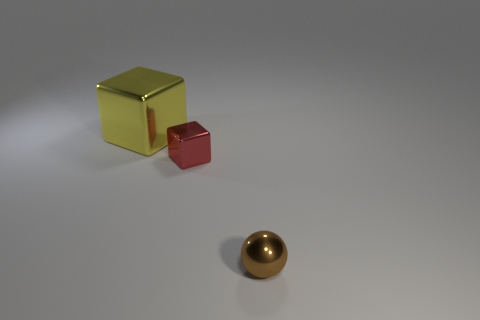What number of purple things are either cubes or big metal things?
Ensure brevity in your answer.  0. Is the number of large blue matte cylinders greater than the number of metallic things?
Ensure brevity in your answer.  No. Does the object on the left side of the small red metallic thing have the same shape as the red metal object?
Your response must be concise. Yes. What number of objects are both in front of the big yellow metallic block and behind the tiny sphere?
Keep it short and to the point. 1. How many other red objects have the same shape as the big thing?
Your response must be concise. 1. What color is the shiny object right of the cube that is in front of the big yellow cube?
Your answer should be compact. Brown. There is a large yellow metallic thing; does it have the same shape as the small thing to the left of the tiny brown thing?
Make the answer very short. Yes. Are there any other metal objects that have the same size as the yellow object?
Provide a succinct answer. No. There is a yellow cube that is the same material as the brown thing; what size is it?
Offer a terse response. Large. What shape is the small brown shiny thing?
Make the answer very short. Sphere. 